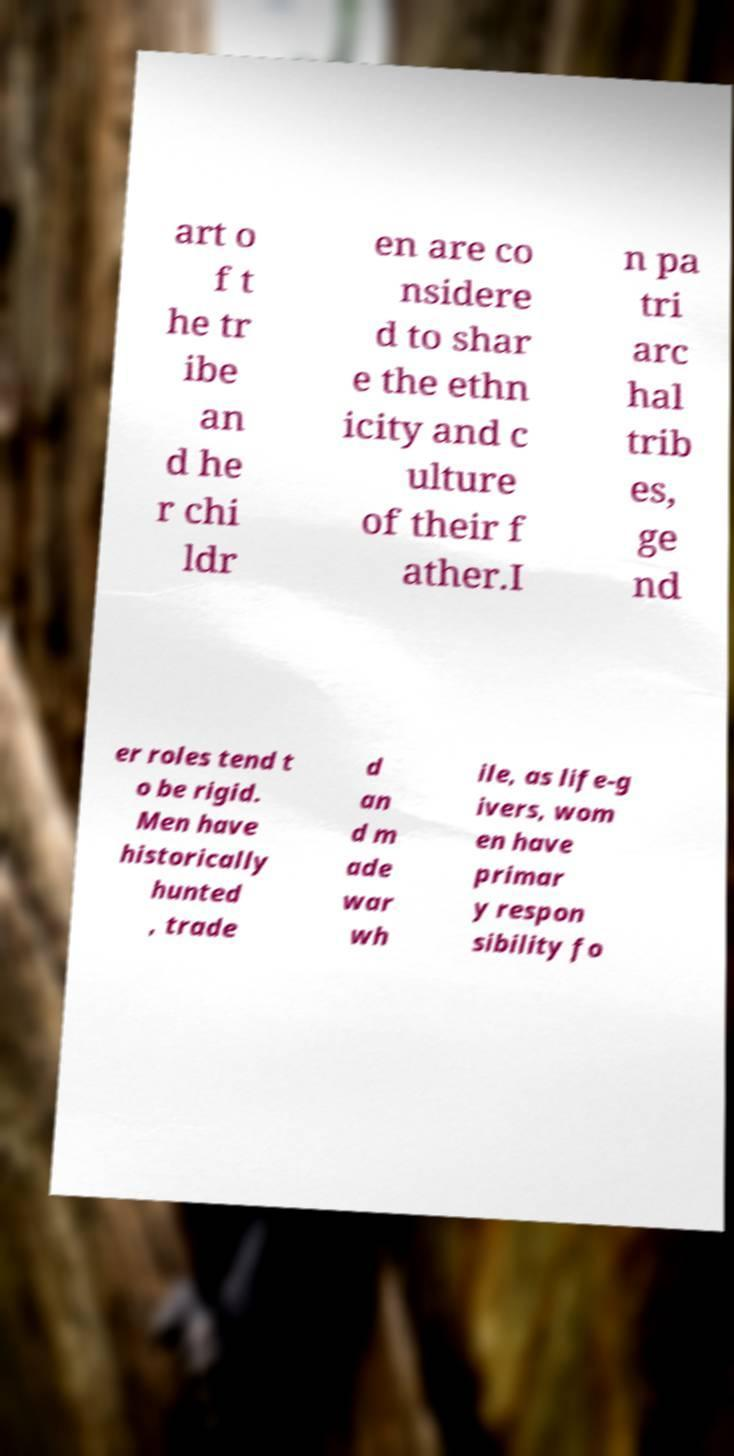Please read and relay the text visible in this image. What does it say? art o f t he tr ibe an d he r chi ldr en are co nsidere d to shar e the ethn icity and c ulture of their f ather.I n pa tri arc hal trib es, ge nd er roles tend t o be rigid. Men have historically hunted , trade d an d m ade war wh ile, as life-g ivers, wom en have primar y respon sibility fo 